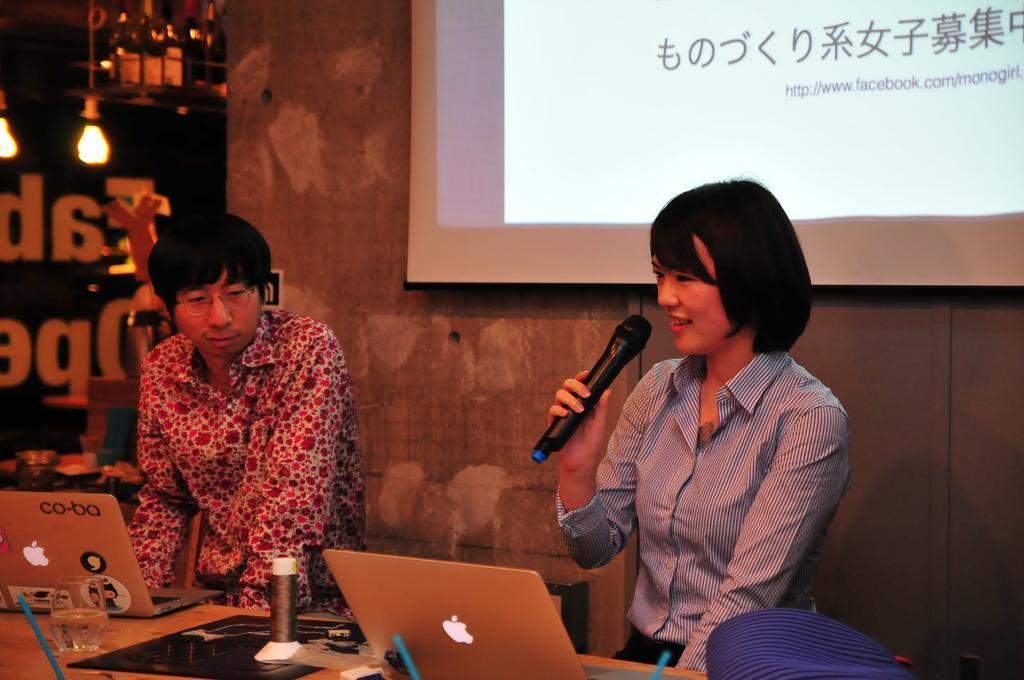Please provide a concise description of this image. in this picture we can see a man and woman where woman is holding mic with her hand and talking and in front of them on table we have laptop, glass with water in it, cap and in the background we can see screen, wall, lights. 